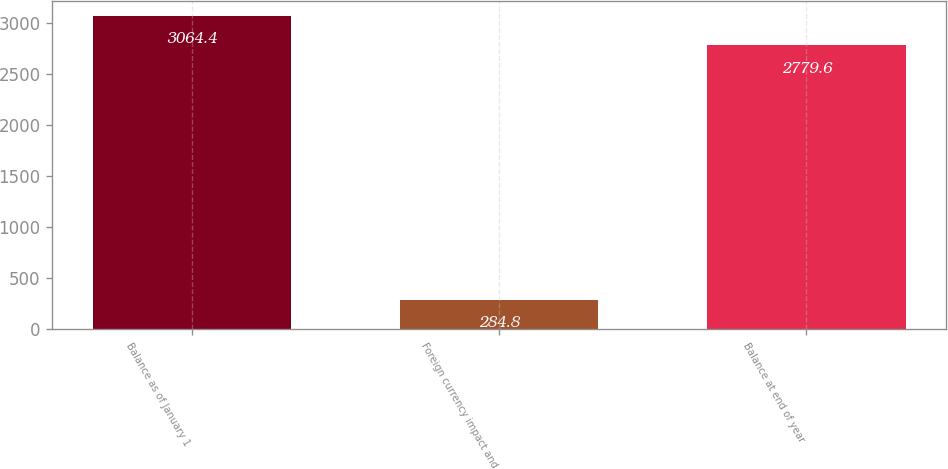Convert chart. <chart><loc_0><loc_0><loc_500><loc_500><bar_chart><fcel>Balance as of January 1<fcel>Foreign currency impact and<fcel>Balance at end of year<nl><fcel>3064.4<fcel>284.8<fcel>2779.6<nl></chart> 